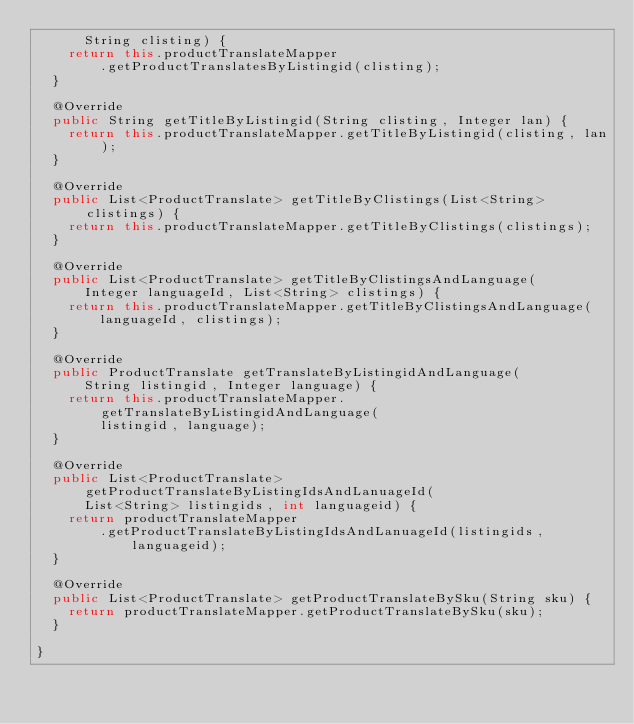Convert code to text. <code><loc_0><loc_0><loc_500><loc_500><_Java_>			String clisting) {
		return this.productTranslateMapper
				.getProductTranslatesByListingid(clisting);
	}

	@Override
	public String getTitleByListingid(String clisting, Integer lan) {
		return this.productTranslateMapper.getTitleByListingid(clisting, lan);
	}

	@Override
	public List<ProductTranslate> getTitleByClistings(List<String> clistings) {
		return this.productTranslateMapper.getTitleByClistings(clistings);
	}

	@Override
	public List<ProductTranslate> getTitleByClistingsAndLanguage(
			Integer languageId, List<String> clistings) {
		return this.productTranslateMapper.getTitleByClistingsAndLanguage(
				languageId, clistings);
	}

	@Override
	public ProductTranslate getTranslateByListingidAndLanguage(
			String listingid, Integer language) {
		return this.productTranslateMapper.getTranslateByListingidAndLanguage(
				listingid, language);
	}

	@Override
	public List<ProductTranslate> getProductTranslateByListingIdsAndLanuageId(
			List<String> listingids, int languageid) {
		return productTranslateMapper
				.getProductTranslateByListingIdsAndLanuageId(listingids,
						languageid);
	}

	@Override
	public List<ProductTranslate> getProductTranslateBySku(String sku) {
		return productTranslateMapper.getProductTranslateBySku(sku);
	}

}
</code> 